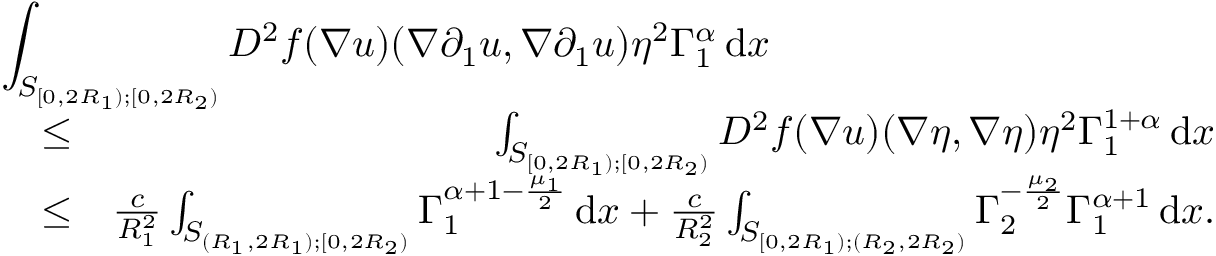<formula> <loc_0><loc_0><loc_500><loc_500>\begin{array} { r l r } { { \int _ { S _ { [ 0 , 2 R _ { 1 } ) ; [ 0 , 2 R _ { 2 } ) } } D ^ { 2 } f ( \nabla u ) ( \nabla \partial _ { 1 } u , \nabla \partial _ { 1 } u ) \eta ^ { 2 } \Gamma _ { 1 } ^ { \alpha } \, d x } } \\ & { \leq } & { \int _ { S _ { [ 0 , 2 R _ { 1 } ) ; [ 0 , 2 R _ { 2 } ) } } D ^ { 2 } f ( \nabla u ) ( \nabla \eta , \nabla \eta ) \eta ^ { 2 } \Gamma _ { 1 } ^ { 1 + \alpha } \, d x } \\ & { \leq } & { \frac { c } { R _ { 1 } ^ { 2 } } \int _ { S _ { ( R _ { 1 } , 2 R _ { 1 } ) ; [ 0 , 2 R _ { 2 } ) } } \Gamma _ { 1 } ^ { \alpha + 1 - \frac { \mu _ { 1 } } { 2 } } \, d x + \frac { c } { R _ { 2 } ^ { 2 } } \int _ { S _ { [ 0 , 2 R _ { 1 } ) ; ( R _ { 2 } , 2 R _ { 2 } ) } } \Gamma _ { 2 } ^ { - \frac { \mu _ { 2 } } { 2 } } \Gamma _ { 1 } ^ { \alpha + 1 } \, d x . } \end{array}</formula> 